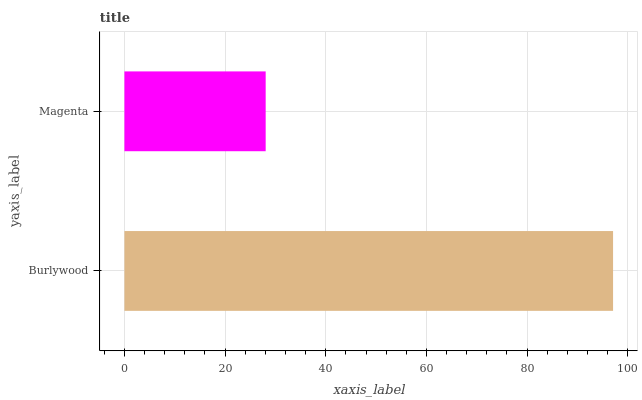Is Magenta the minimum?
Answer yes or no. Yes. Is Burlywood the maximum?
Answer yes or no. Yes. Is Magenta the maximum?
Answer yes or no. No. Is Burlywood greater than Magenta?
Answer yes or no. Yes. Is Magenta less than Burlywood?
Answer yes or no. Yes. Is Magenta greater than Burlywood?
Answer yes or no. No. Is Burlywood less than Magenta?
Answer yes or no. No. Is Burlywood the high median?
Answer yes or no. Yes. Is Magenta the low median?
Answer yes or no. Yes. Is Magenta the high median?
Answer yes or no. No. Is Burlywood the low median?
Answer yes or no. No. 